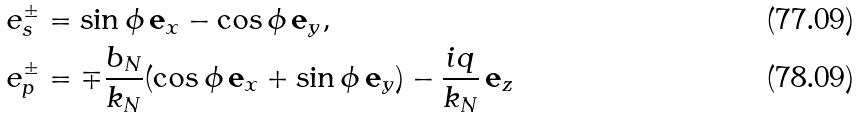Convert formula to latex. <formula><loc_0><loc_0><loc_500><loc_500>& e _ { s } ^ { \pm } = \sin { \phi } \, { \mathbf e } _ { x } - \cos \phi \, { \mathbf e } _ { y } , \\ & e _ { p } ^ { \pm } = \mp \frac { b _ { N } } { k _ { N } } ( \cos \phi \, { \mathbf e } _ { x } + \sin \phi \, { \mathbf e } _ { y } ) - \frac { i q } { k _ { N } } \, { \mathbf e } _ { z }</formula> 